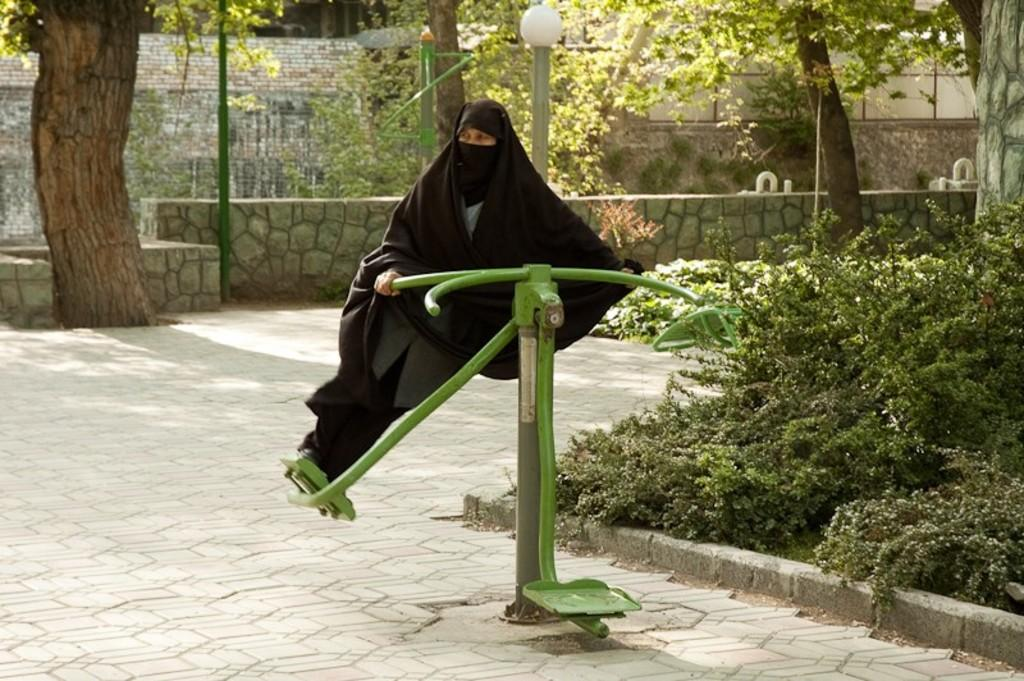What is the person in the image doing? The person is on the playground equipment. What type of vegetation can be seen in the image? There are plants, trees, and a wall in the background of the image. What structures are present in the image? There are poles in the image. What type of lamp is being used by the servant in the image? There is no lamp or servant present in the image. What hobbies does the person on the playground equipment enjoy? The provided facts do not give information about the person's hobbies, so we cannot answer this question. 